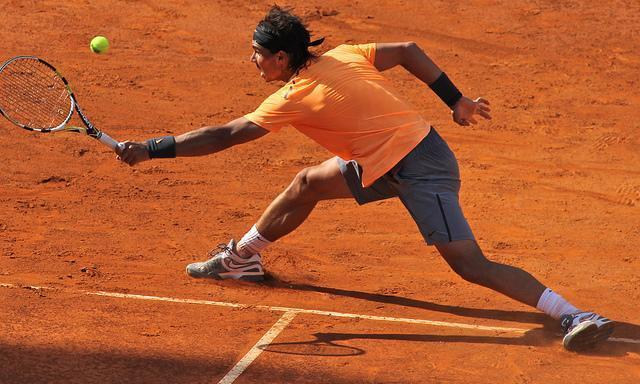How many tennis rackets are there?
Give a very brief answer. 1. 